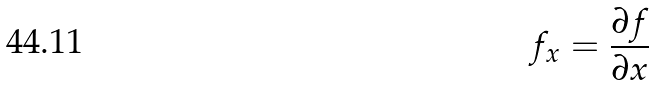Convert formula to latex. <formula><loc_0><loc_0><loc_500><loc_500>f _ { x } = \frac { \partial f } { \partial x }</formula> 